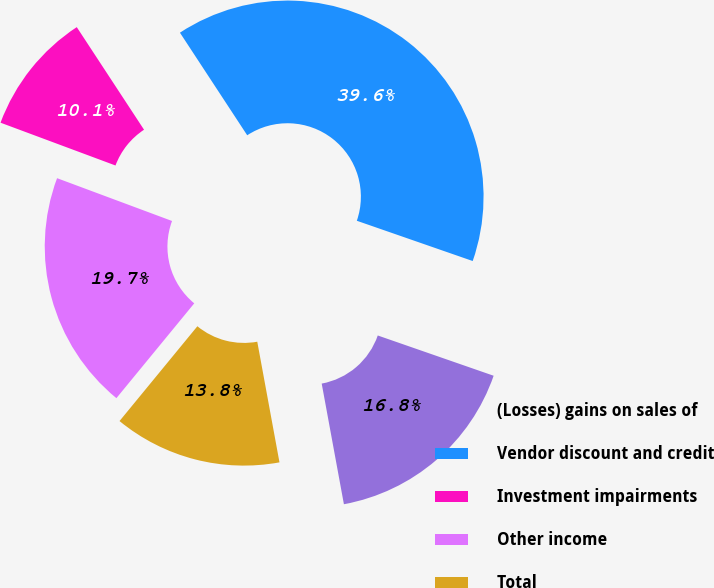<chart> <loc_0><loc_0><loc_500><loc_500><pie_chart><fcel>(Losses) gains on sales of<fcel>Vendor discount and credit<fcel>Investment impairments<fcel>Other income<fcel>Total<nl><fcel>16.78%<fcel>39.56%<fcel>10.09%<fcel>19.73%<fcel>13.84%<nl></chart> 